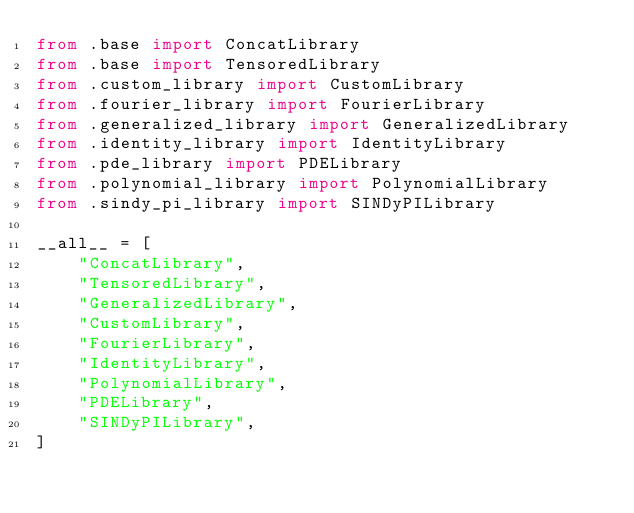Convert code to text. <code><loc_0><loc_0><loc_500><loc_500><_Python_>from .base import ConcatLibrary
from .base import TensoredLibrary
from .custom_library import CustomLibrary
from .fourier_library import FourierLibrary
from .generalized_library import GeneralizedLibrary
from .identity_library import IdentityLibrary
from .pde_library import PDELibrary
from .polynomial_library import PolynomialLibrary
from .sindy_pi_library import SINDyPILibrary

__all__ = [
    "ConcatLibrary",
    "TensoredLibrary",
    "GeneralizedLibrary",
    "CustomLibrary",
    "FourierLibrary",
    "IdentityLibrary",
    "PolynomialLibrary",
    "PDELibrary",
    "SINDyPILibrary",
]
</code> 